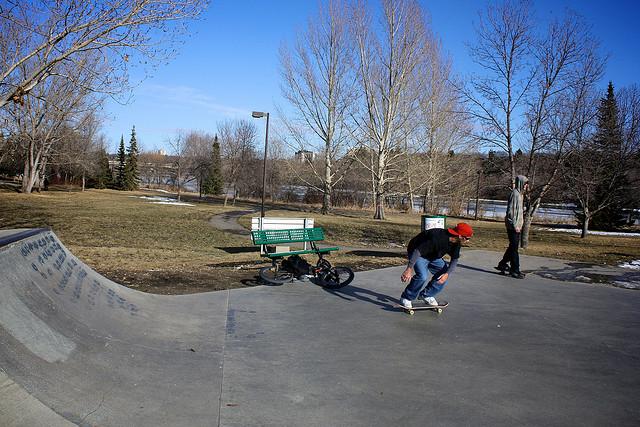What season is it?
Short answer required. Fall. What is this place?
Quick response, please. Skate park. How many methods of transportation are seen here?
Concise answer only. 2. What color is the boy's t shirt?
Keep it brief. Black. 